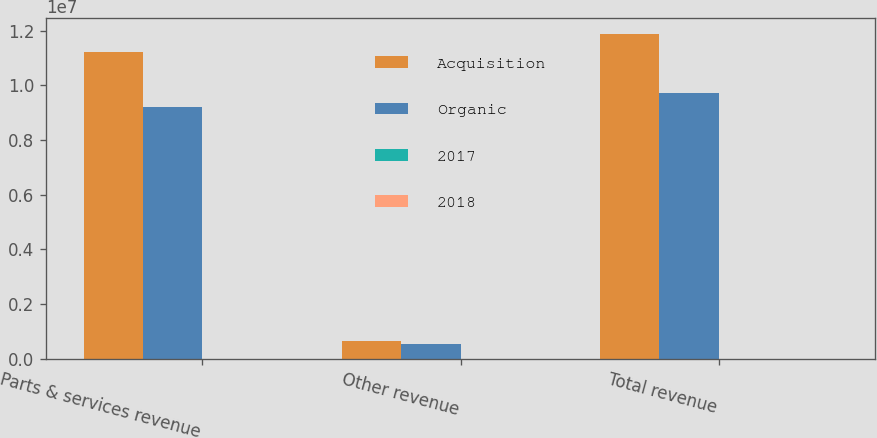<chart> <loc_0><loc_0><loc_500><loc_500><stacked_bar_chart><ecel><fcel>Parts & services revenue<fcel>Other revenue<fcel>Total revenue<nl><fcel>Acquisition<fcel>1.12334e+07<fcel>643267<fcel>1.18767e+07<nl><fcel>Organic<fcel>9.20863e+06<fcel>528275<fcel>9.73691e+06<nl><fcel>2017<fcel>4.4<fcel>20.4<fcel>5.3<nl><fcel>2018<fcel>16<fcel>1.4<fcel>15.3<nl></chart> 